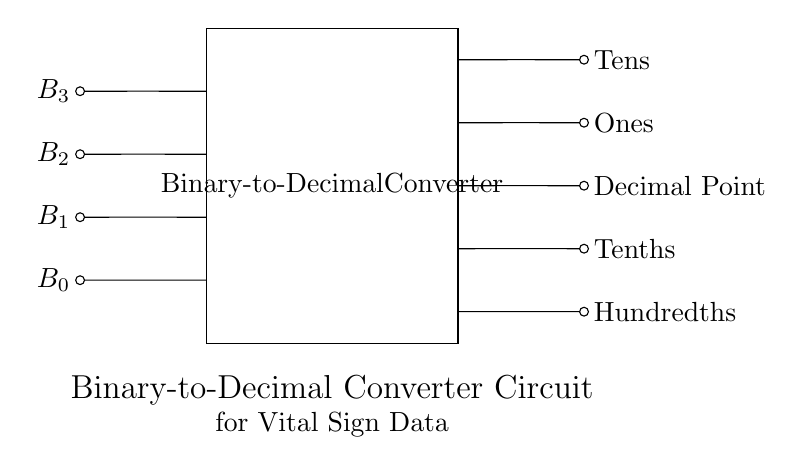What are the input signals for this circuit? The input signals for this binary-to-decimal converter circuit are labeled as B3, B2, B1, and B0, which represent the binary digits being converted.
Answer: B3, B2, B1, B0 What is the output for the tenths place? In the circuit, the tenths place output is indicated as one of the outputs listed, which directly corresponds to the binary inputs being processed by the converter.
Answer: Tenths How many output lines are there from the converter? The output from the binary-to-decimal converter includes five lines: Tens, Ones, Decimal Point, Tenths, and Hundredths. Counting these gives a total of five output lines.
Answer: Five What is the primary function of this circuit? The primary function of this circuit is to convert binary inputs representing encoded vital signs into decimal outputs that are more readable, thus aiding in clarity for medical data interpretation.
Answer: Convert binary to decimal If B3 is 1, B2 is 0, B1 is 1, and B0 is 0, what is the decimal output? To determine the decimal output for the binary input of 1010, We calculate it as follows: B3 contributes 8, B2 contributes 0, B1 contributes 2, and B0 contributes 0. Adding these gives 8 + 0 + 2 + 0 = 10.
Answer: Ten 